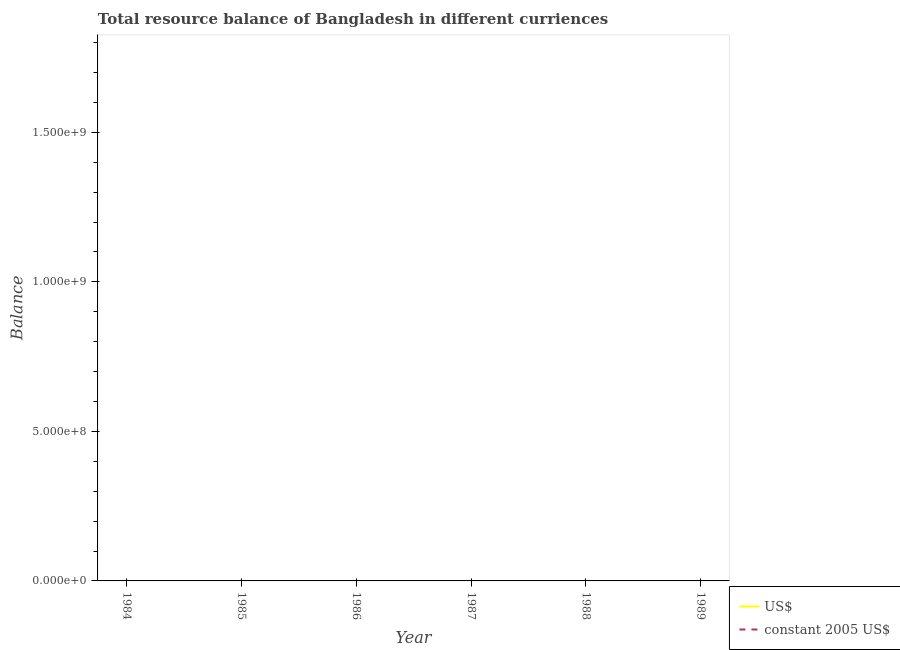How many different coloured lines are there?
Your answer should be compact. 0. What is the resource balance in constant us$ in 1987?
Your answer should be compact. 0. What is the difference between the resource balance in constant us$ in 1989 and the resource balance in us$ in 1986?
Your answer should be compact. 0. What is the average resource balance in constant us$ per year?
Offer a very short reply. 0. In how many years, is the resource balance in constant us$ greater than 1600000000 units?
Provide a succinct answer. 0. In how many years, is the resource balance in constant us$ greater than the average resource balance in constant us$ taken over all years?
Your answer should be compact. 0. Is the resource balance in us$ strictly greater than the resource balance in constant us$ over the years?
Your answer should be compact. Yes. How many lines are there?
Offer a terse response. 0. How many years are there in the graph?
Your response must be concise. 6. Are the values on the major ticks of Y-axis written in scientific E-notation?
Your answer should be very brief. Yes. Does the graph contain any zero values?
Provide a short and direct response. Yes. How many legend labels are there?
Keep it short and to the point. 2. What is the title of the graph?
Your answer should be very brief. Total resource balance of Bangladesh in different curriences. What is the label or title of the Y-axis?
Provide a short and direct response. Balance. What is the Balance of US$ in 1985?
Provide a succinct answer. 0. What is the Balance in constant 2005 US$ in 1985?
Your answer should be compact. 0. What is the Balance in constant 2005 US$ in 1986?
Make the answer very short. 0. What is the Balance in constant 2005 US$ in 1988?
Keep it short and to the point. 0. What is the average Balance in US$ per year?
Provide a short and direct response. 0. What is the average Balance in constant 2005 US$ per year?
Your answer should be very brief. 0. 